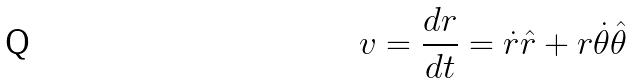Convert formula to latex. <formula><loc_0><loc_0><loc_500><loc_500>v = \frac { d r } { d t } = \dot { r } \hat { r } + r \dot { \theta } \hat { \theta }</formula> 